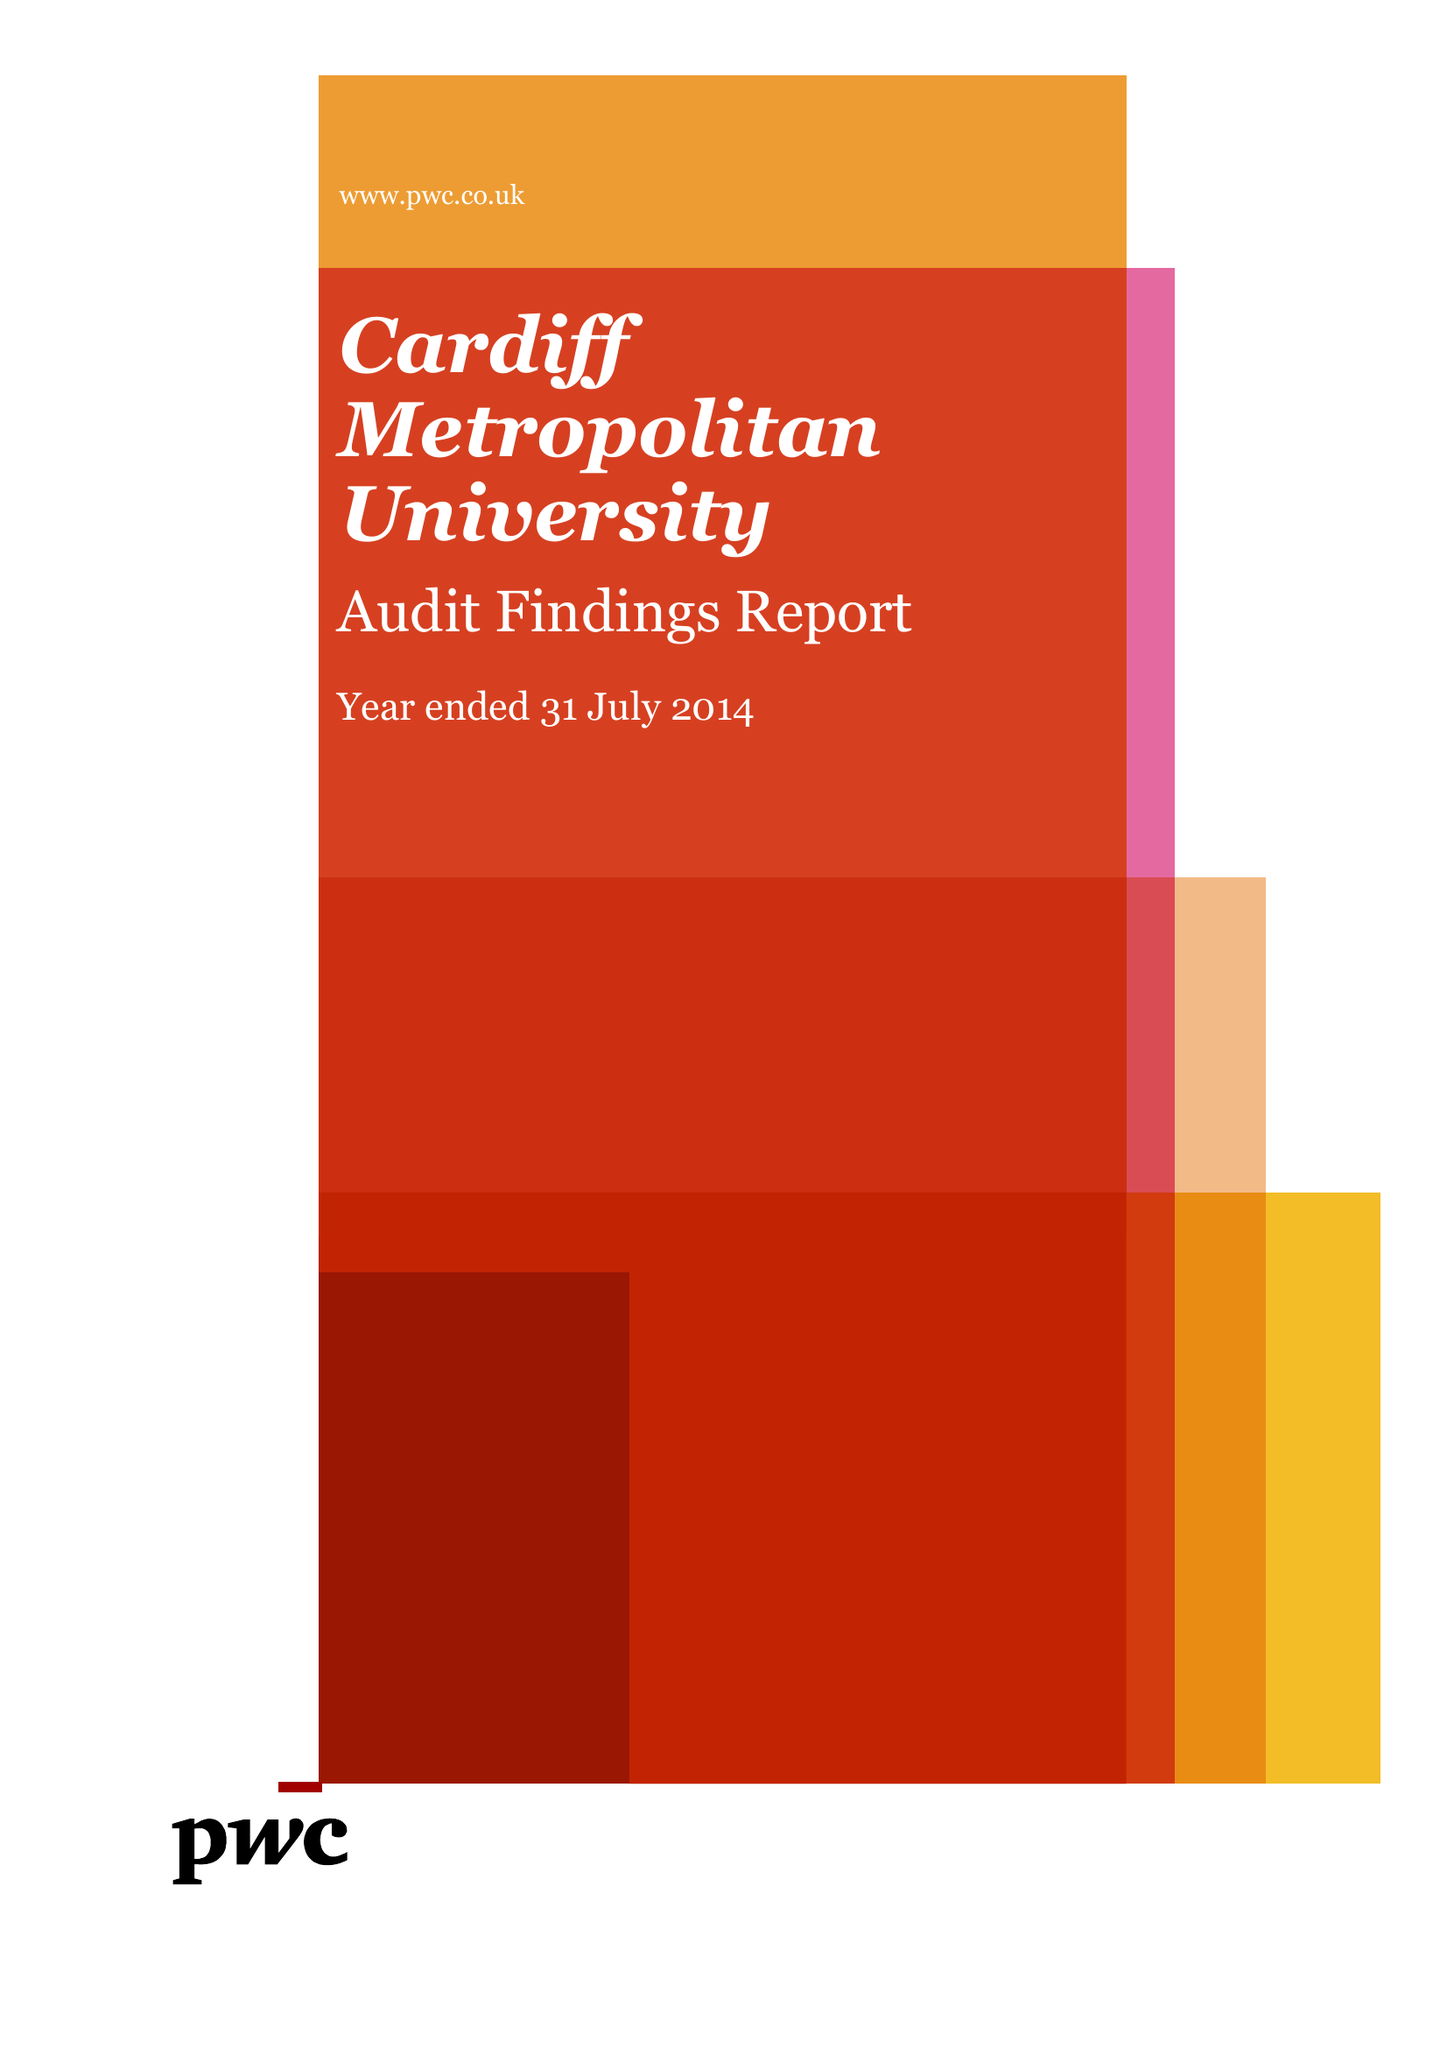What is the value for the charity_name?
Answer the question using a single word or phrase. Cardiff Metropolitan University 